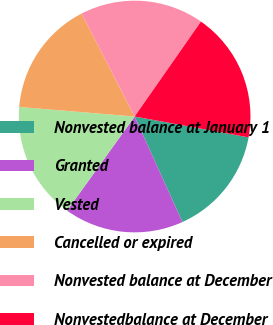<chart> <loc_0><loc_0><loc_500><loc_500><pie_chart><fcel>Nonvested balance at January 1<fcel>Granted<fcel>Vested<fcel>Cancelled or expired<fcel>Nonvested balance at December<fcel>Nonvestedbalance at December<nl><fcel>15.35%<fcel>16.68%<fcel>16.4%<fcel>16.12%<fcel>17.27%<fcel>18.18%<nl></chart> 